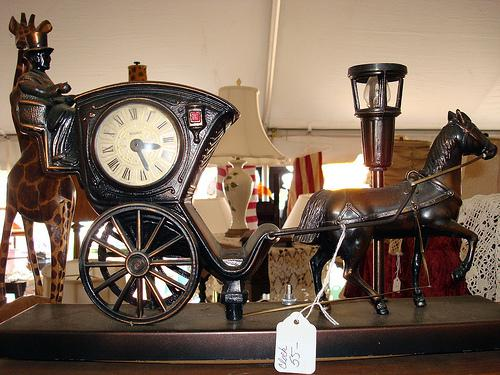Question: who will see it?
Choices:
A. The children.
B. Adults.
C. People.
D. Teenagers.
Answer with the letter. Answer: C Question: where is it?
Choices:
A. Store.
B. The restaurant.
C. Gas station.
D. Grocery store.
Answer with the letter. Answer: A 